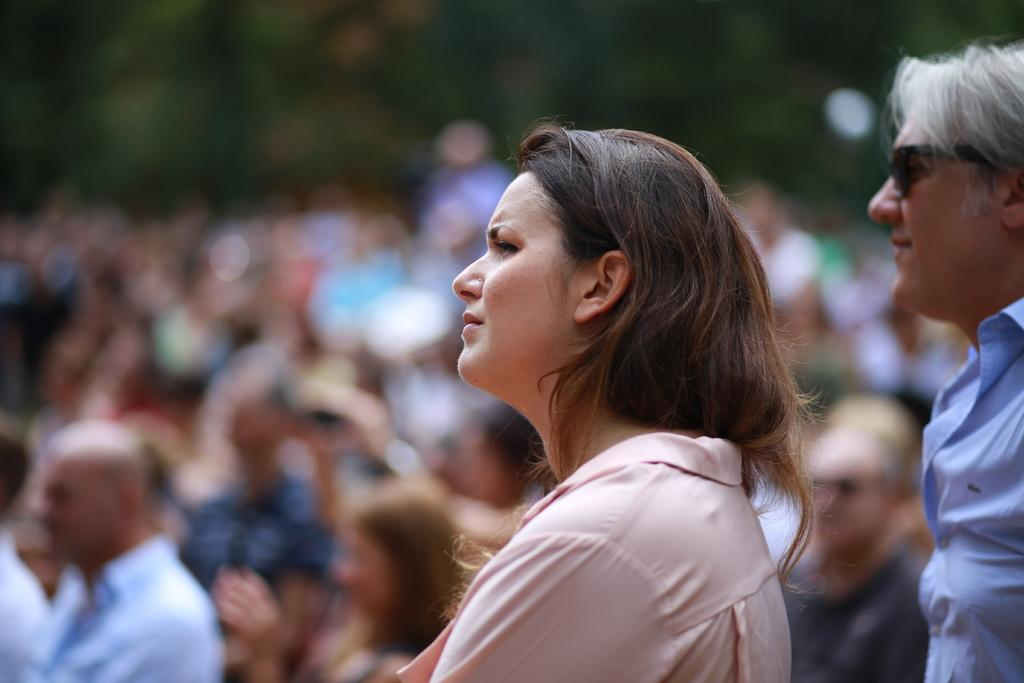How many people are visible in the image? There is a man and a woman in the image, making a total of two people. What are the man and woman wearing? The man is wearing a blue shirt, and the woman is wearing a pink shirt. Can you describe the people behind the man and woman? Unfortunately, the facts provided do not give any information about the people behind the man and woman. What is the weather like in the image? The facts provided do not give any information about the weather in the image. What division does the calendar in the image belong to? There is no calendar present in the image. 